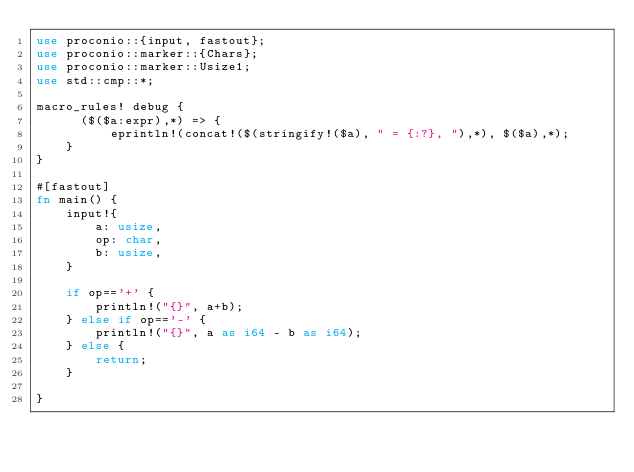Convert code to text. <code><loc_0><loc_0><loc_500><loc_500><_Rust_>use proconio::{input, fastout};
use proconio::marker::{Chars};
use proconio::marker::Usize1;
use std::cmp::*;

macro_rules! debug {
      ($($a:expr),*) => {
          eprintln!(concat!($(stringify!($a), " = {:?}, "),*), $($a),*);
    }
}

#[fastout]
fn main() {
    input!{
        a: usize,
        op: char,
        b: usize,
    }

    if op=='+' {
        println!("{}", a+b);
    } else if op=='-' {
        println!("{}", a as i64 - b as i64);
    } else {
        return;
    }

}
</code> 